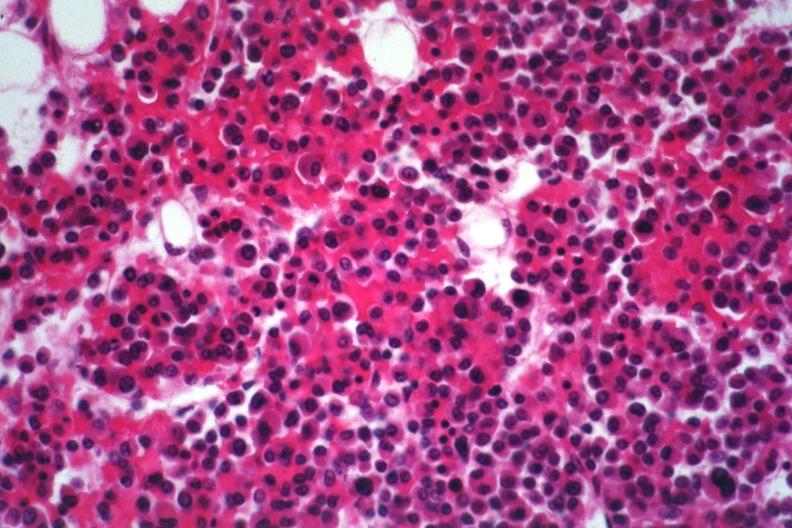s bone, mandible present?
Answer the question using a single word or phrase. No 